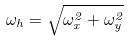Convert formula to latex. <formula><loc_0><loc_0><loc_500><loc_500>\omega _ { h } = \sqrt { \omega _ { x } ^ { 2 } + \omega _ { y } ^ { 2 } }</formula> 